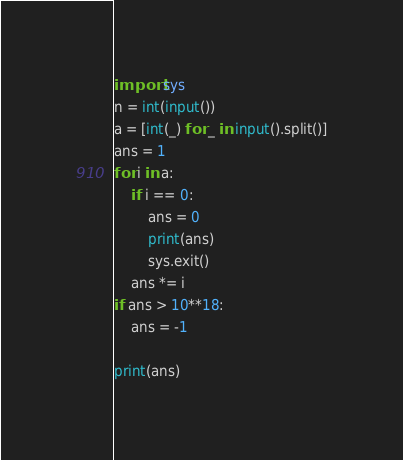Convert code to text. <code><loc_0><loc_0><loc_500><loc_500><_Python_>import sys
n = int(input())
a = [int(_) for _ in input().split()]
ans = 1
for i in a:
    if i == 0:
        ans = 0
        print(ans)
        sys.exit()
    ans *= i
if ans > 10**18:
    ans = -1

print(ans)
</code> 